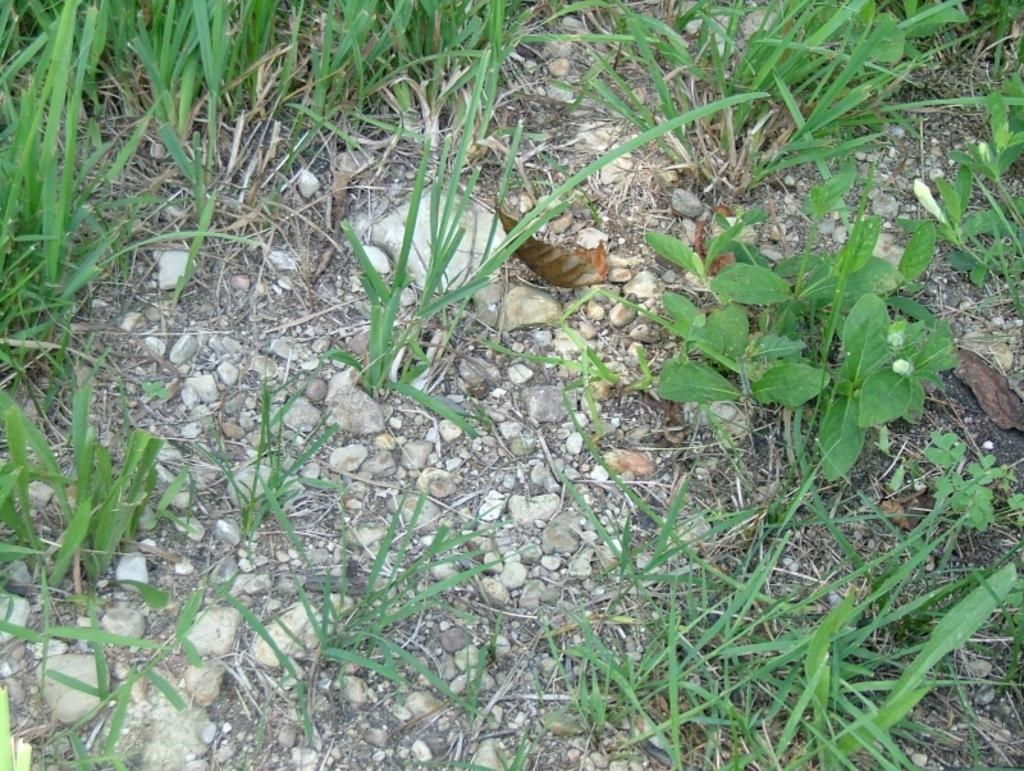What type of living organisms can be seen in the image? Plants can be seen in the image. What can be found on the ground in the image? There are stones on the ground in the image. What color is the yak's fang in the image? There is no yak or fang present in the image; it only features plants and stones on the ground. 